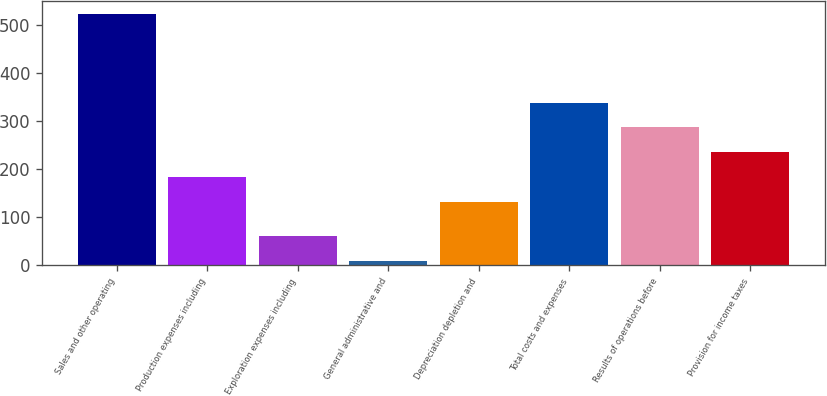<chart> <loc_0><loc_0><loc_500><loc_500><bar_chart><fcel>Sales and other operating<fcel>Production expenses including<fcel>Exploration expenses including<fcel>General administrative and<fcel>Depreciation depletion and<fcel>Total costs and expenses<fcel>Results of operations before<fcel>Provision for income taxes<nl><fcel>524<fcel>184.5<fcel>60.5<fcel>9<fcel>133<fcel>339<fcel>287.5<fcel>236<nl></chart> 